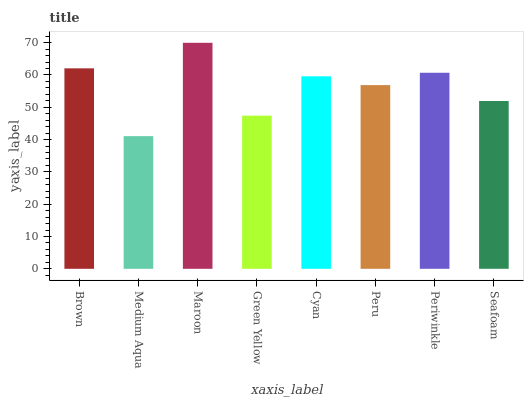Is Medium Aqua the minimum?
Answer yes or no. Yes. Is Maroon the maximum?
Answer yes or no. Yes. Is Maroon the minimum?
Answer yes or no. No. Is Medium Aqua the maximum?
Answer yes or no. No. Is Maroon greater than Medium Aqua?
Answer yes or no. Yes. Is Medium Aqua less than Maroon?
Answer yes or no. Yes. Is Medium Aqua greater than Maroon?
Answer yes or no. No. Is Maroon less than Medium Aqua?
Answer yes or no. No. Is Cyan the high median?
Answer yes or no. Yes. Is Peru the low median?
Answer yes or no. Yes. Is Brown the high median?
Answer yes or no. No. Is Brown the low median?
Answer yes or no. No. 